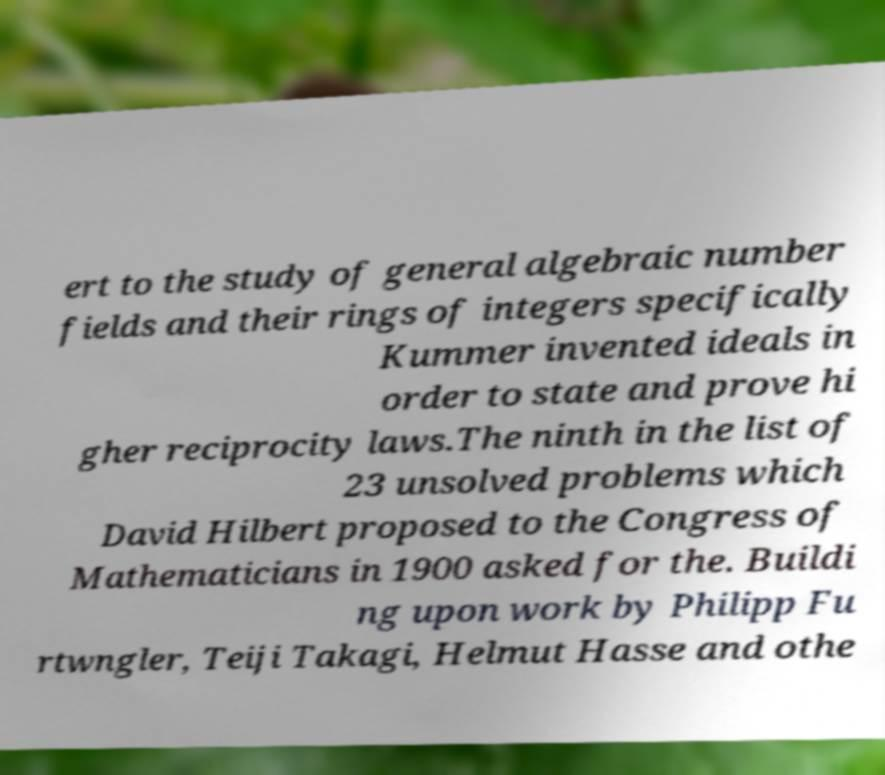What messages or text are displayed in this image? I need them in a readable, typed format. ert to the study of general algebraic number fields and their rings of integers specifically Kummer invented ideals in order to state and prove hi gher reciprocity laws.The ninth in the list of 23 unsolved problems which David Hilbert proposed to the Congress of Mathematicians in 1900 asked for the. Buildi ng upon work by Philipp Fu rtwngler, Teiji Takagi, Helmut Hasse and othe 